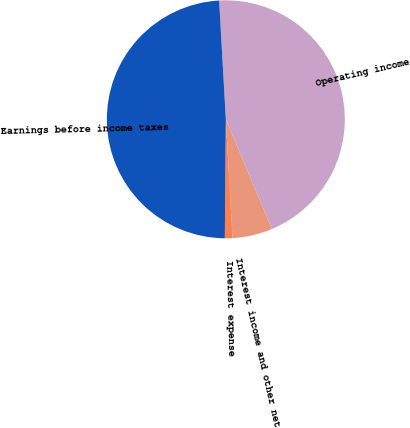<chart> <loc_0><loc_0><loc_500><loc_500><pie_chart><fcel>Operating income<fcel>Interest income and other net<fcel>Interest expense<fcel>Earnings before income taxes<nl><fcel>44.56%<fcel>5.44%<fcel>1.03%<fcel>48.97%<nl></chart> 